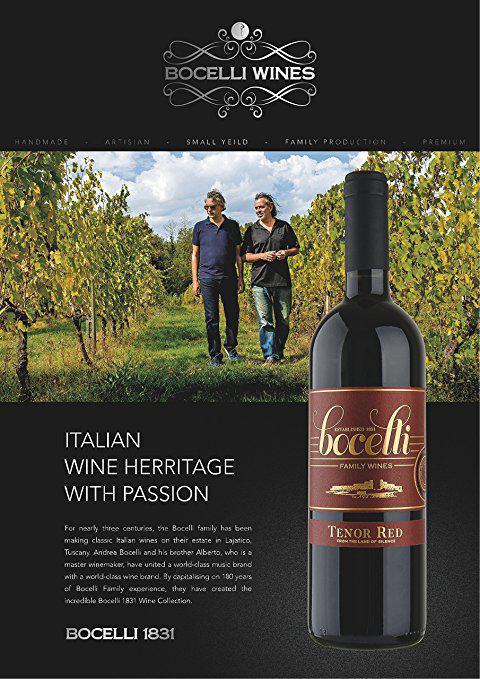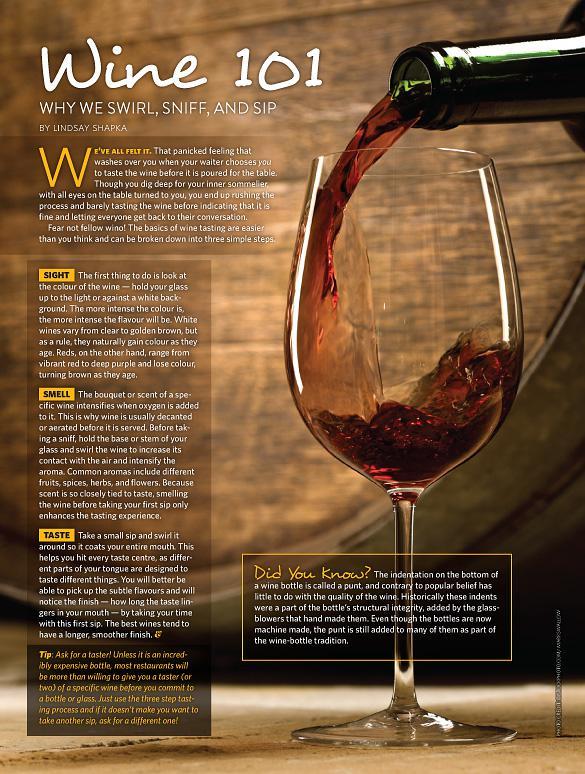The first image is the image on the left, the second image is the image on the right. Assess this claim about the two images: "A full glass of wine is to the left of a bottle of wine on in the right image.". Correct or not? Answer yes or no. No. 